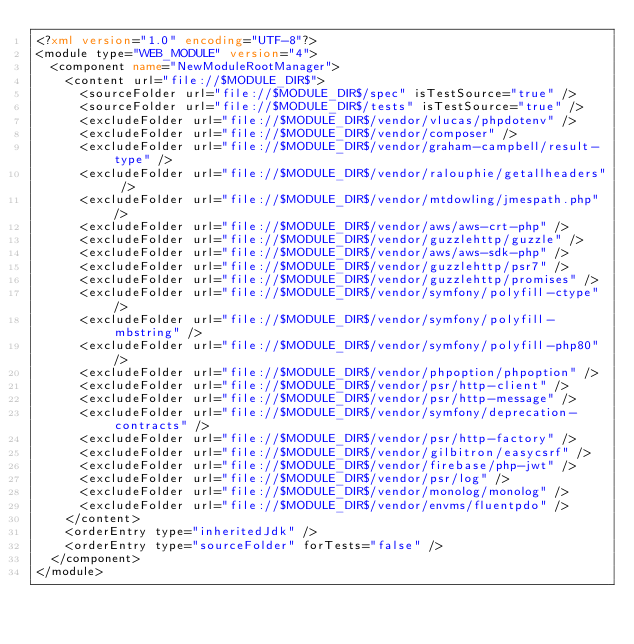Convert code to text. <code><loc_0><loc_0><loc_500><loc_500><_XML_><?xml version="1.0" encoding="UTF-8"?>
<module type="WEB_MODULE" version="4">
  <component name="NewModuleRootManager">
    <content url="file://$MODULE_DIR$">
      <sourceFolder url="file://$MODULE_DIR$/spec" isTestSource="true" />
      <sourceFolder url="file://$MODULE_DIR$/tests" isTestSource="true" />
      <excludeFolder url="file://$MODULE_DIR$/vendor/vlucas/phpdotenv" />
      <excludeFolder url="file://$MODULE_DIR$/vendor/composer" />
      <excludeFolder url="file://$MODULE_DIR$/vendor/graham-campbell/result-type" />
      <excludeFolder url="file://$MODULE_DIR$/vendor/ralouphie/getallheaders" />
      <excludeFolder url="file://$MODULE_DIR$/vendor/mtdowling/jmespath.php" />
      <excludeFolder url="file://$MODULE_DIR$/vendor/aws/aws-crt-php" />
      <excludeFolder url="file://$MODULE_DIR$/vendor/guzzlehttp/guzzle" />
      <excludeFolder url="file://$MODULE_DIR$/vendor/aws/aws-sdk-php" />
      <excludeFolder url="file://$MODULE_DIR$/vendor/guzzlehttp/psr7" />
      <excludeFolder url="file://$MODULE_DIR$/vendor/guzzlehttp/promises" />
      <excludeFolder url="file://$MODULE_DIR$/vendor/symfony/polyfill-ctype" />
      <excludeFolder url="file://$MODULE_DIR$/vendor/symfony/polyfill-mbstring" />
      <excludeFolder url="file://$MODULE_DIR$/vendor/symfony/polyfill-php80" />
      <excludeFolder url="file://$MODULE_DIR$/vendor/phpoption/phpoption" />
      <excludeFolder url="file://$MODULE_DIR$/vendor/psr/http-client" />
      <excludeFolder url="file://$MODULE_DIR$/vendor/psr/http-message" />
      <excludeFolder url="file://$MODULE_DIR$/vendor/symfony/deprecation-contracts" />
      <excludeFolder url="file://$MODULE_DIR$/vendor/psr/http-factory" />
      <excludeFolder url="file://$MODULE_DIR$/vendor/gilbitron/easycsrf" />
      <excludeFolder url="file://$MODULE_DIR$/vendor/firebase/php-jwt" />
      <excludeFolder url="file://$MODULE_DIR$/vendor/psr/log" />
      <excludeFolder url="file://$MODULE_DIR$/vendor/monolog/monolog" />
      <excludeFolder url="file://$MODULE_DIR$/vendor/envms/fluentpdo" />
    </content>
    <orderEntry type="inheritedJdk" />
    <orderEntry type="sourceFolder" forTests="false" />
  </component>
</module></code> 